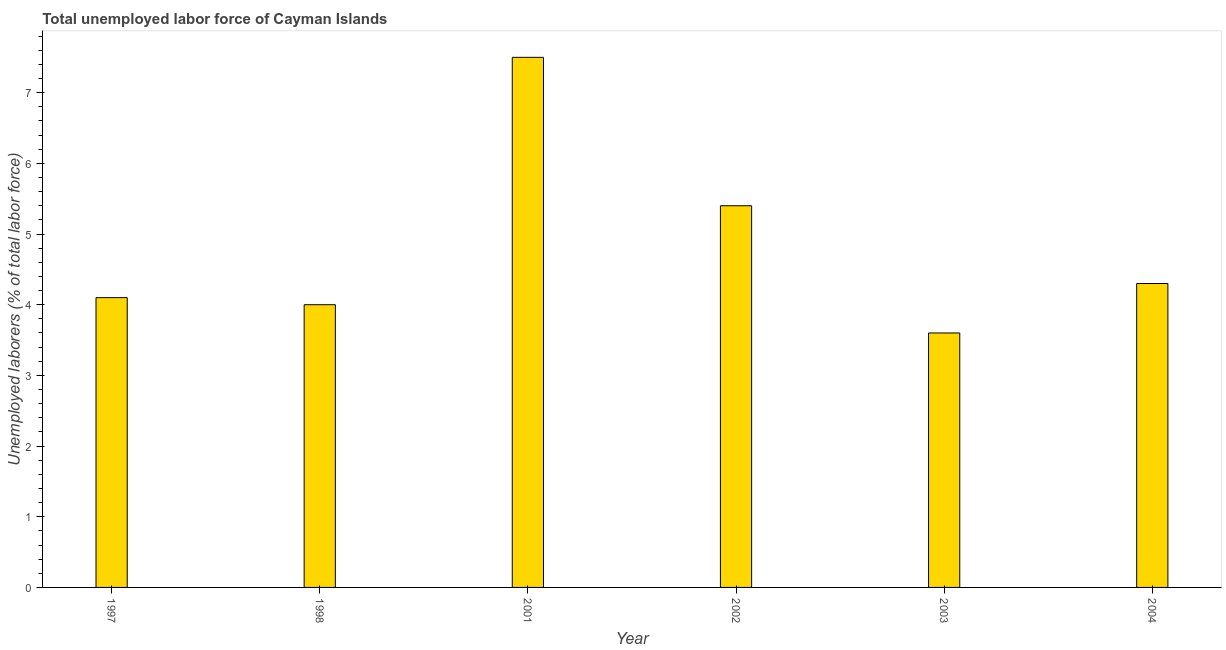What is the title of the graph?
Keep it short and to the point. Total unemployed labor force of Cayman Islands. What is the label or title of the X-axis?
Provide a short and direct response. Year. What is the label or title of the Y-axis?
Make the answer very short. Unemployed laborers (% of total labor force). What is the total unemployed labour force in 2003?
Keep it short and to the point. 3.6. Across all years, what is the maximum total unemployed labour force?
Offer a terse response. 7.5. Across all years, what is the minimum total unemployed labour force?
Your answer should be very brief. 3.6. In which year was the total unemployed labour force minimum?
Provide a short and direct response. 2003. What is the sum of the total unemployed labour force?
Your response must be concise. 28.9. What is the average total unemployed labour force per year?
Offer a terse response. 4.82. What is the median total unemployed labour force?
Provide a succinct answer. 4.2. Do a majority of the years between 1998 and 2001 (inclusive) have total unemployed labour force greater than 2.6 %?
Ensure brevity in your answer.  Yes. What is the ratio of the total unemployed labour force in 1997 to that in 2001?
Provide a short and direct response. 0.55. What is the difference between the highest and the lowest total unemployed labour force?
Offer a terse response. 3.9. Are all the bars in the graph horizontal?
Give a very brief answer. No. How many years are there in the graph?
Keep it short and to the point. 6. What is the difference between two consecutive major ticks on the Y-axis?
Give a very brief answer. 1. Are the values on the major ticks of Y-axis written in scientific E-notation?
Make the answer very short. No. What is the Unemployed laborers (% of total labor force) of 1997?
Make the answer very short. 4.1. What is the Unemployed laborers (% of total labor force) in 2001?
Offer a very short reply. 7.5. What is the Unemployed laborers (% of total labor force) of 2002?
Provide a short and direct response. 5.4. What is the Unemployed laborers (% of total labor force) of 2003?
Provide a succinct answer. 3.6. What is the Unemployed laborers (% of total labor force) of 2004?
Make the answer very short. 4.3. What is the difference between the Unemployed laborers (% of total labor force) in 1997 and 1998?
Offer a terse response. 0.1. What is the difference between the Unemployed laborers (% of total labor force) in 1997 and 2001?
Offer a terse response. -3.4. What is the difference between the Unemployed laborers (% of total labor force) in 1997 and 2002?
Your answer should be compact. -1.3. What is the difference between the Unemployed laborers (% of total labor force) in 1997 and 2003?
Your answer should be very brief. 0.5. What is the difference between the Unemployed laborers (% of total labor force) in 1997 and 2004?
Offer a very short reply. -0.2. What is the difference between the Unemployed laborers (% of total labor force) in 1998 and 2002?
Your answer should be very brief. -1.4. What is the difference between the Unemployed laborers (% of total labor force) in 1998 and 2003?
Your answer should be very brief. 0.4. What is the difference between the Unemployed laborers (% of total labor force) in 2002 and 2003?
Make the answer very short. 1.8. What is the difference between the Unemployed laborers (% of total labor force) in 2003 and 2004?
Your answer should be very brief. -0.7. What is the ratio of the Unemployed laborers (% of total labor force) in 1997 to that in 1998?
Ensure brevity in your answer.  1.02. What is the ratio of the Unemployed laborers (% of total labor force) in 1997 to that in 2001?
Give a very brief answer. 0.55. What is the ratio of the Unemployed laborers (% of total labor force) in 1997 to that in 2002?
Ensure brevity in your answer.  0.76. What is the ratio of the Unemployed laborers (% of total labor force) in 1997 to that in 2003?
Keep it short and to the point. 1.14. What is the ratio of the Unemployed laborers (% of total labor force) in 1997 to that in 2004?
Offer a very short reply. 0.95. What is the ratio of the Unemployed laborers (% of total labor force) in 1998 to that in 2001?
Provide a short and direct response. 0.53. What is the ratio of the Unemployed laborers (% of total labor force) in 1998 to that in 2002?
Offer a very short reply. 0.74. What is the ratio of the Unemployed laborers (% of total labor force) in 1998 to that in 2003?
Offer a terse response. 1.11. What is the ratio of the Unemployed laborers (% of total labor force) in 1998 to that in 2004?
Provide a short and direct response. 0.93. What is the ratio of the Unemployed laborers (% of total labor force) in 2001 to that in 2002?
Your answer should be very brief. 1.39. What is the ratio of the Unemployed laborers (% of total labor force) in 2001 to that in 2003?
Give a very brief answer. 2.08. What is the ratio of the Unemployed laborers (% of total labor force) in 2001 to that in 2004?
Ensure brevity in your answer.  1.74. What is the ratio of the Unemployed laborers (% of total labor force) in 2002 to that in 2003?
Provide a short and direct response. 1.5. What is the ratio of the Unemployed laborers (% of total labor force) in 2002 to that in 2004?
Give a very brief answer. 1.26. What is the ratio of the Unemployed laborers (% of total labor force) in 2003 to that in 2004?
Give a very brief answer. 0.84. 